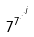<formula> <loc_0><loc_0><loc_500><loc_500>7 ^ { 7 ^ { \cdot ^ { \cdot ^ { \cdot ^ { j } } } } }</formula> 